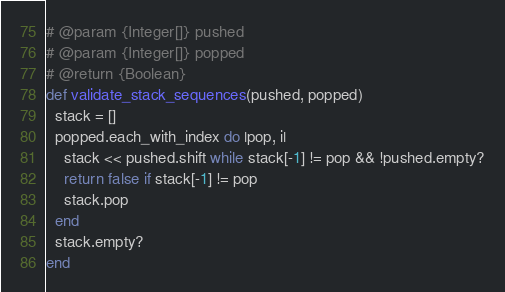Convert code to text. <code><loc_0><loc_0><loc_500><loc_500><_Ruby_># @param {Integer[]} pushed
# @param {Integer[]} popped
# @return {Boolean}
def validate_stack_sequences(pushed, popped)
  stack = []
  popped.each_with_index do |pop, i|
    stack << pushed.shift while stack[-1] != pop && !pushed.empty?
    return false if stack[-1] != pop
    stack.pop
  end
  stack.empty?
end
</code> 